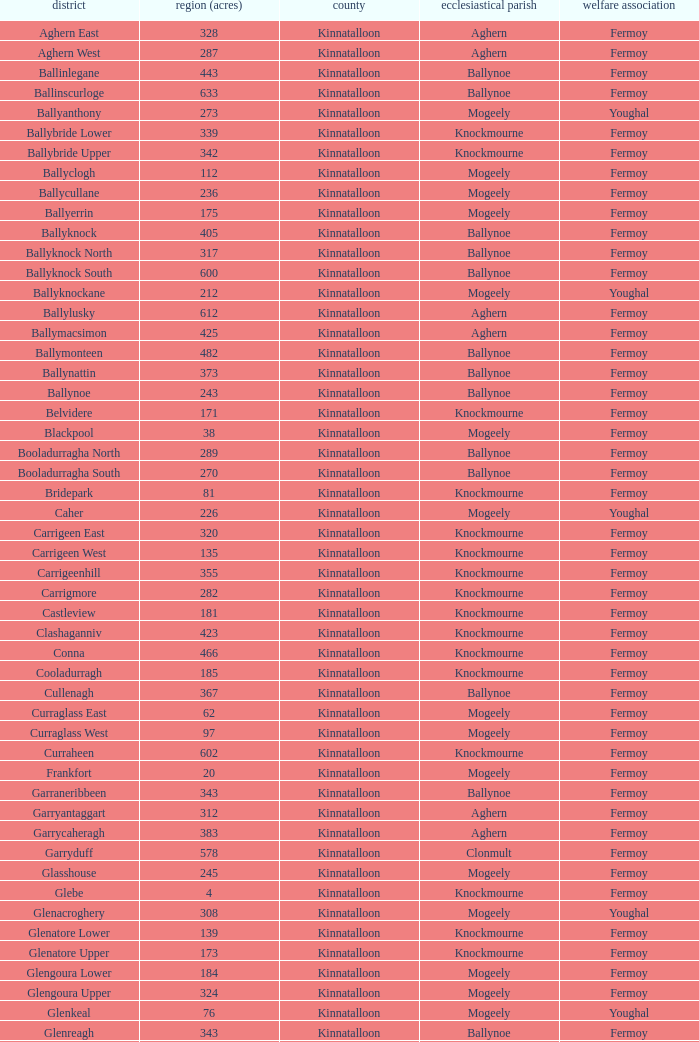Name  the townland for fermoy and ballynoe Ballinlegane, Ballinscurloge, Ballyknock, Ballyknock North, Ballyknock South, Ballymonteen, Ballynattin, Ballynoe, Booladurragha North, Booladurragha South, Cullenagh, Garraneribbeen, Glenreagh, Glentane, Killasseragh, Kilphillibeen, Knockakeo, Longueville North, Longueville South, Rathdrum, Shanaboola. 